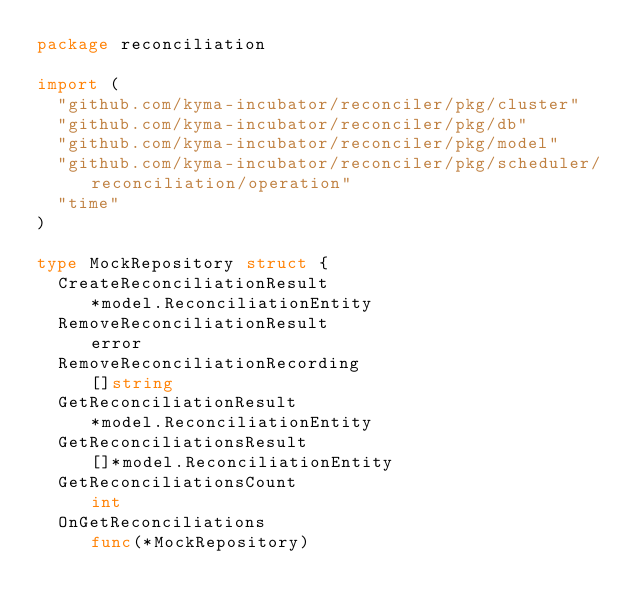Convert code to text. <code><loc_0><loc_0><loc_500><loc_500><_Go_>package reconciliation

import (
	"github.com/kyma-incubator/reconciler/pkg/cluster"
	"github.com/kyma-incubator/reconciler/pkg/db"
	"github.com/kyma-incubator/reconciler/pkg/model"
	"github.com/kyma-incubator/reconciler/pkg/scheduler/reconciliation/operation"
	"time"
)

type MockRepository struct {
	CreateReconciliationResult                          *model.ReconciliationEntity
	RemoveReconciliationResult                          error
	RemoveReconciliationRecording                       []string
	GetReconciliationResult                             *model.ReconciliationEntity
	GetReconciliationsResult                            []*model.ReconciliationEntity
	GetReconciliationsCount                             int
	OnGetReconciliations                                func(*MockRepository)</code> 